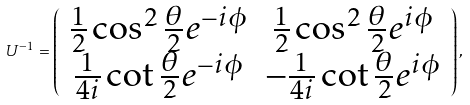<formula> <loc_0><loc_0><loc_500><loc_500>U ^ { - 1 } = \left ( \begin{array} { c c } \frac { 1 } { 2 } \cos ^ { 2 } \frac { \theta } { 2 } e ^ { - i \phi } & \frac { 1 } { 2 } \cos ^ { 2 } \frac { \theta } { 2 } e ^ { i \phi } \\ \frac { 1 } { 4 i } \cot \frac { \theta } { 2 } e ^ { - i \phi } & - \frac { 1 } { 4 i } \cot \frac { \theta } { 2 } e ^ { i \phi } \end{array} \right ) ,</formula> 